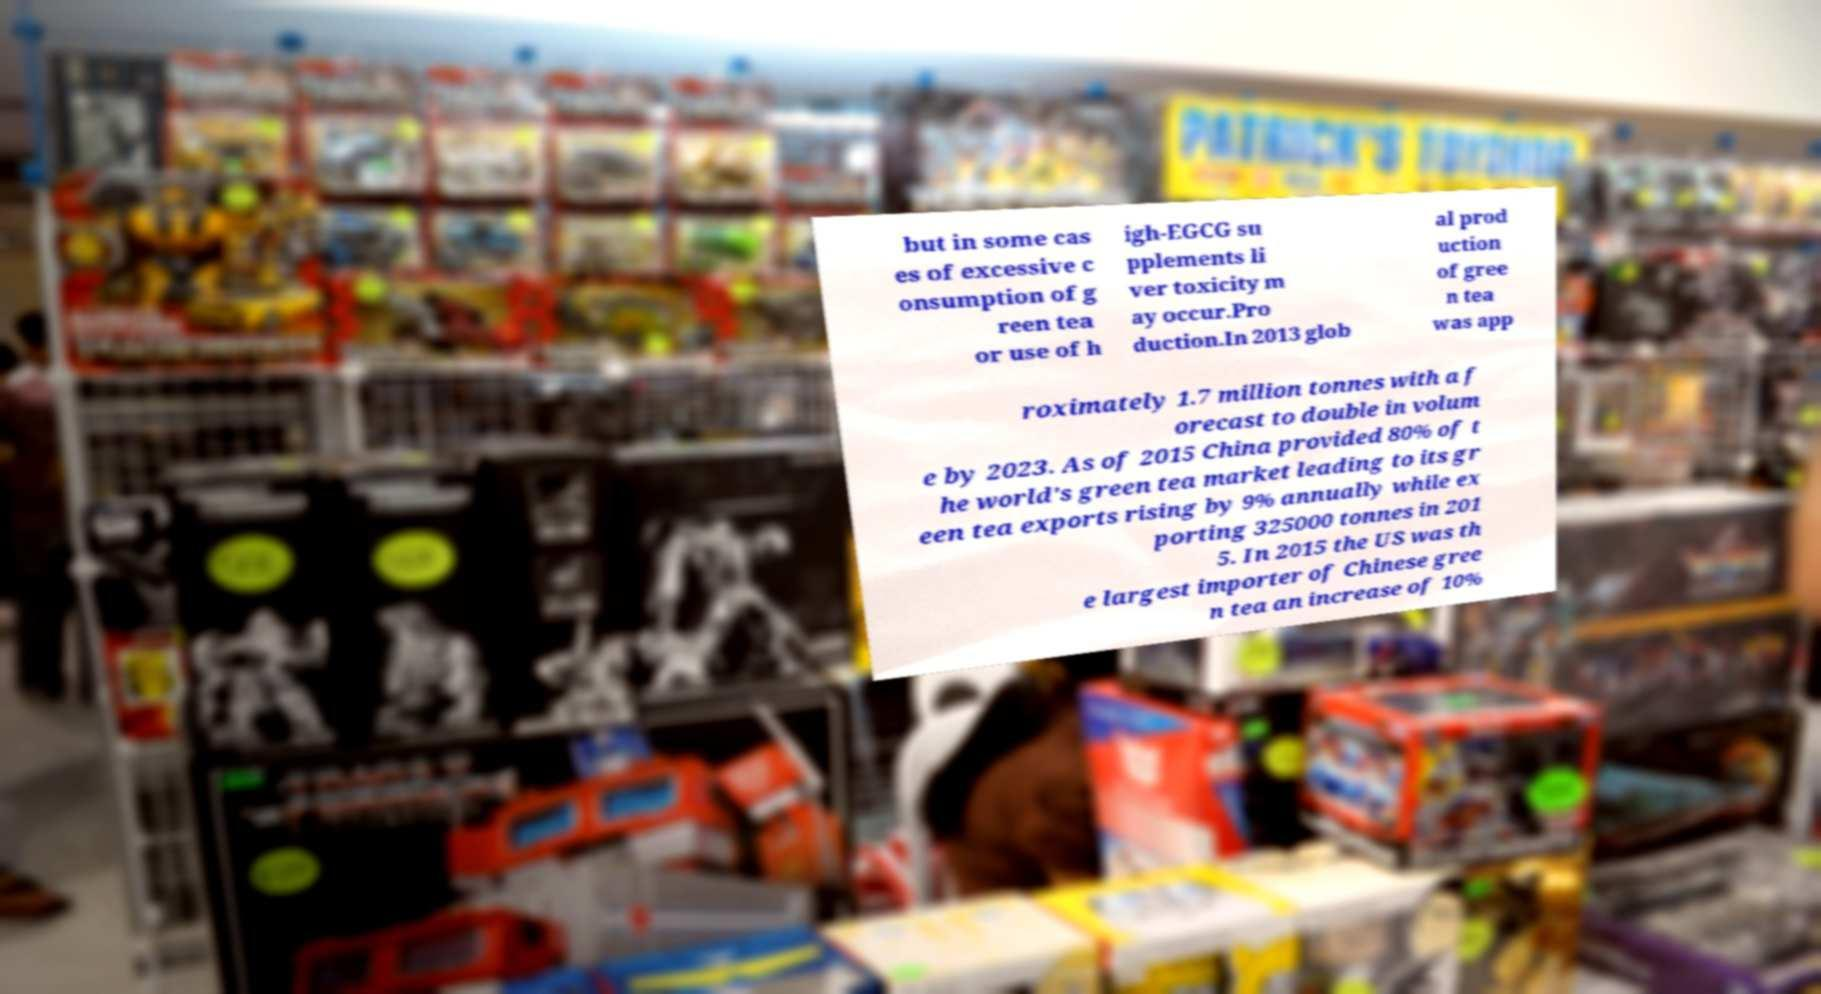Can you accurately transcribe the text from the provided image for me? but in some cas es of excessive c onsumption of g reen tea or use of h igh-EGCG su pplements li ver toxicity m ay occur.Pro duction.In 2013 glob al prod uction of gree n tea was app roximately 1.7 million tonnes with a f orecast to double in volum e by 2023. As of 2015 China provided 80% of t he world's green tea market leading to its gr een tea exports rising by 9% annually while ex porting 325000 tonnes in 201 5. In 2015 the US was th e largest importer of Chinese gree n tea an increase of 10% 